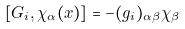<formula> <loc_0><loc_0><loc_500><loc_500>[ G _ { i } , \chi _ { \alpha } ( x ) ] = - ( g _ { i } ) _ { \alpha \beta } \chi _ { \beta }</formula> 